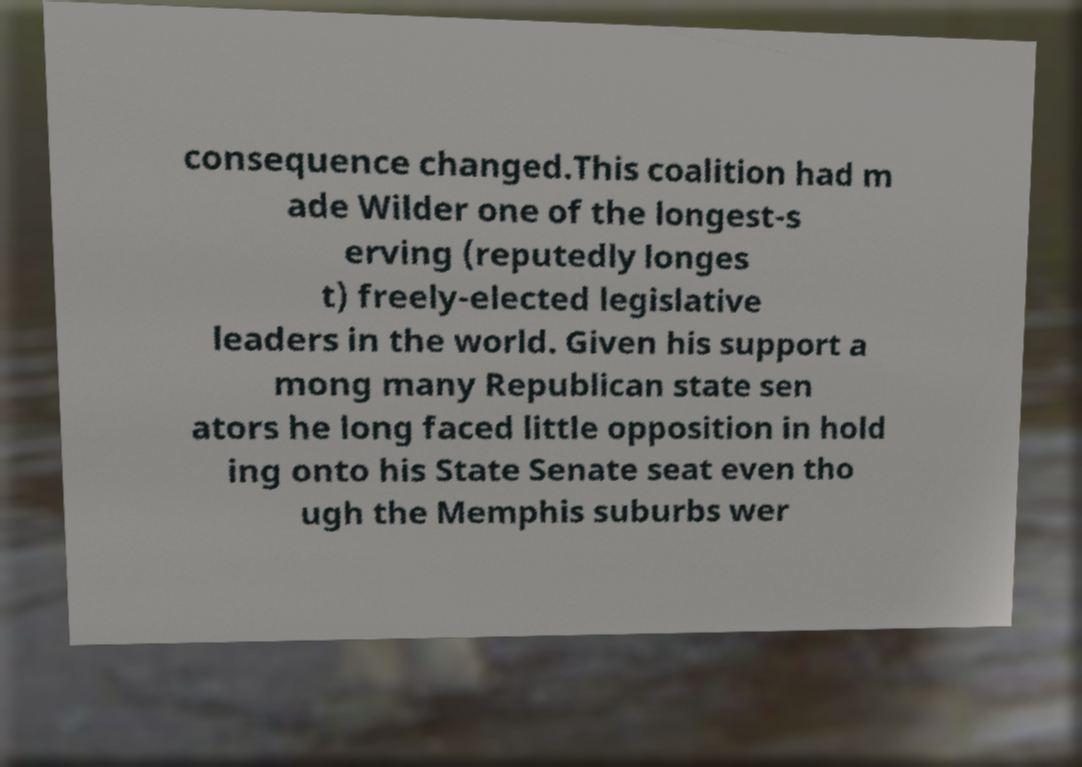Can you read and provide the text displayed in the image?This photo seems to have some interesting text. Can you extract and type it out for me? consequence changed.This coalition had m ade Wilder one of the longest-s erving (reputedly longes t) freely-elected legislative leaders in the world. Given his support a mong many Republican state sen ators he long faced little opposition in hold ing onto his State Senate seat even tho ugh the Memphis suburbs wer 